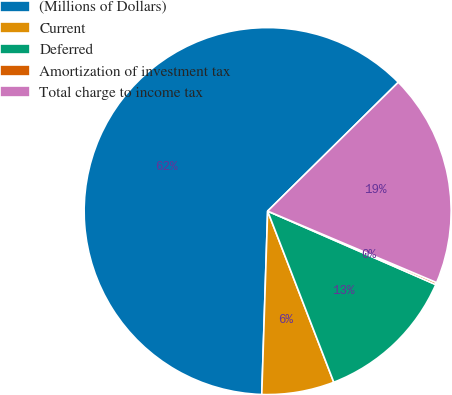Convert chart. <chart><loc_0><loc_0><loc_500><loc_500><pie_chart><fcel>(Millions of Dollars)<fcel>Current<fcel>Deferred<fcel>Amortization of investment tax<fcel>Total charge to income tax<nl><fcel>62.11%<fcel>6.38%<fcel>12.57%<fcel>0.19%<fcel>18.76%<nl></chart> 